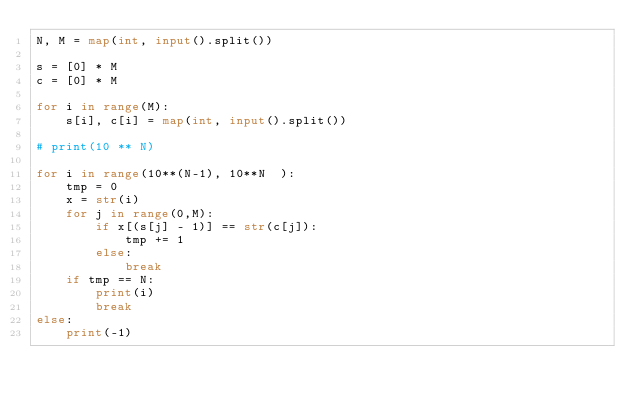<code> <loc_0><loc_0><loc_500><loc_500><_Python_>N, M = map(int, input().split())

s = [0] * M
c = [0] * M

for i in range(M):
    s[i], c[i] = map(int, input().split())

# print(10 ** N)

for i in range(10**(N-1), 10**N  ):
    tmp = 0
    x = str(i)
    for j in range(0,M):
        if x[(s[j] - 1)] == str(c[j]):
            tmp += 1
        else:
            break
    if tmp == N:
        print(i)
        break
else:
    print(-1)
</code> 